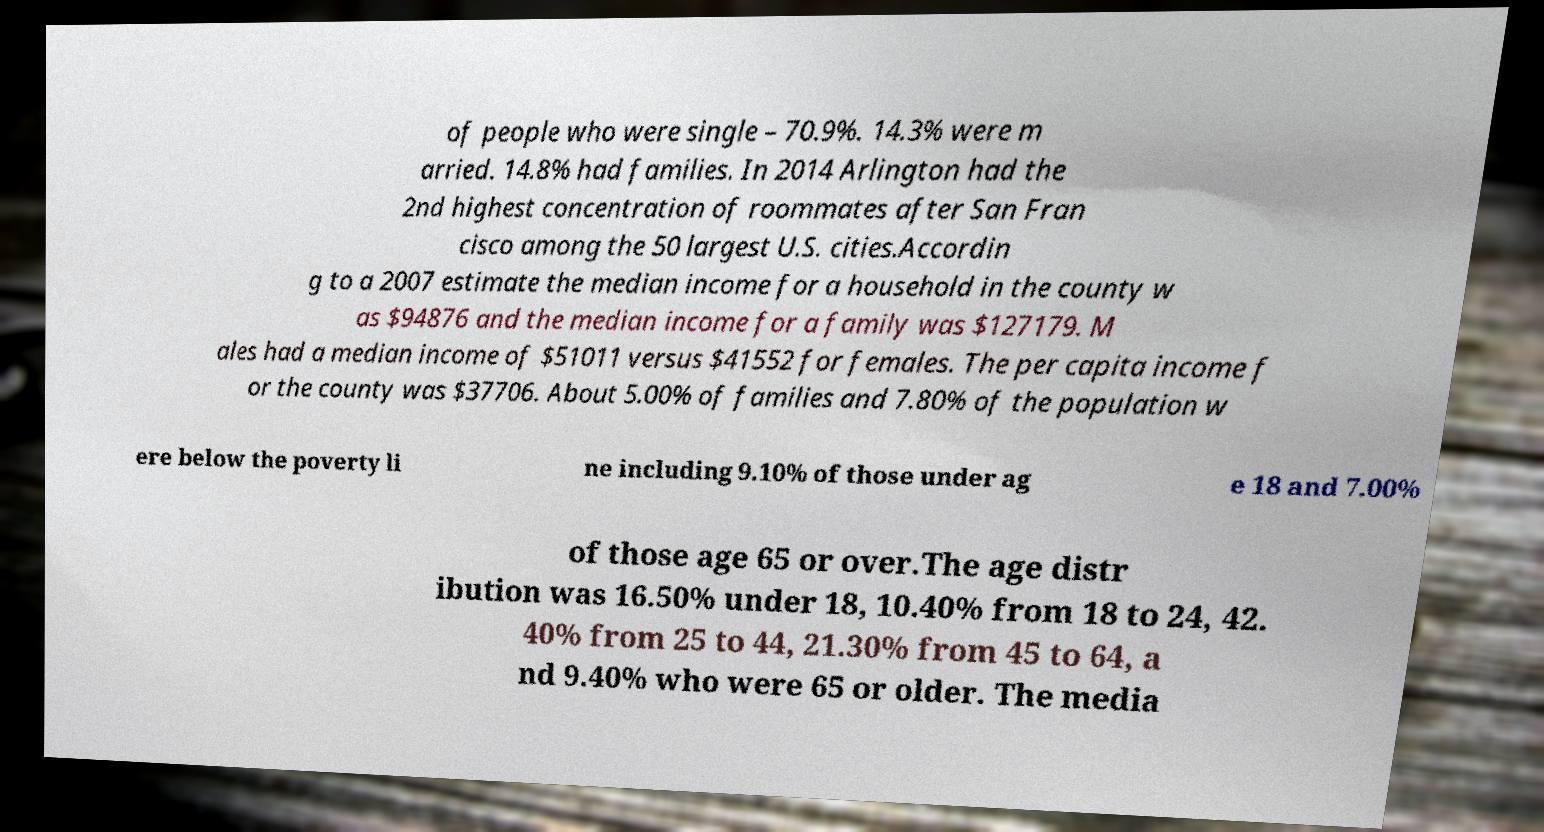For documentation purposes, I need the text within this image transcribed. Could you provide that? of people who were single – 70.9%. 14.3% were m arried. 14.8% had families. In 2014 Arlington had the 2nd highest concentration of roommates after San Fran cisco among the 50 largest U.S. cities.Accordin g to a 2007 estimate the median income for a household in the county w as $94876 and the median income for a family was $127179. M ales had a median income of $51011 versus $41552 for females. The per capita income f or the county was $37706. About 5.00% of families and 7.80% of the population w ere below the poverty li ne including 9.10% of those under ag e 18 and 7.00% of those age 65 or over.The age distr ibution was 16.50% under 18, 10.40% from 18 to 24, 42. 40% from 25 to 44, 21.30% from 45 to 64, a nd 9.40% who were 65 or older. The media 